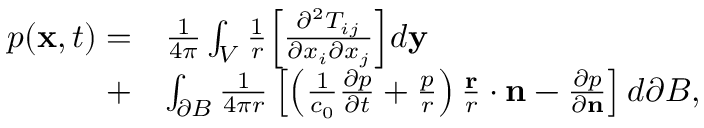Convert formula to latex. <formula><loc_0><loc_0><loc_500><loc_500>\begin{array} { r l } { p ( x , t ) = } & { \frac { 1 } { 4 \pi } \int _ { V } \frac { 1 } { r } \left [ \frac { \partial ^ { 2 } T _ { i j } } { \partial x _ { i } \partial x _ { j } } \right ] d y } \\ { + } & { \int _ { \partial B } \frac { 1 } { 4 \pi r } \left [ \left ( \frac { 1 } { c _ { 0 } } \frac { \partial p } { \partial t } + \frac { p } { r } \right ) \frac { r } { r } \cdot n - \frac { \partial p } { \partial n } \right ] d \partial B , } \end{array}</formula> 